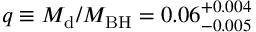<formula> <loc_0><loc_0><loc_500><loc_500>q \equiv M _ { d } / { M _ { B H } } = 0 . 0 6 _ { - 0 . 0 0 5 } ^ { + 0 . 0 0 4 }</formula> 